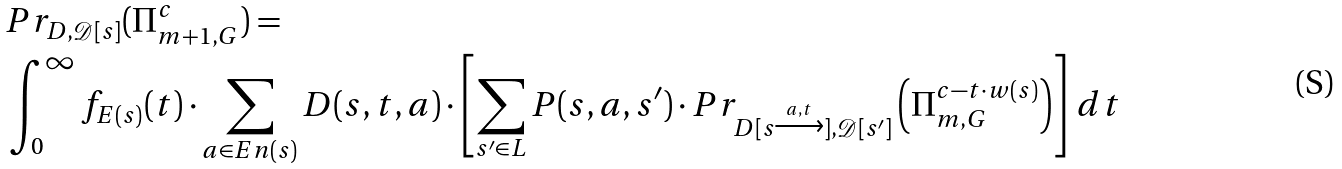<formula> <loc_0><loc_0><loc_500><loc_500>& P r _ { D , \mathcal { D } [ s ] } ( \Pi ^ { c } _ { m + 1 , G } ) = \\ & \int _ { 0 } ^ { \infty } f _ { E ( s ) } ( t ) \cdot \sum _ { a \in E n ( s ) } D ( s , t , a ) \cdot \left [ \sum _ { s ^ { \prime } \in L } P ( s , a , s ^ { \prime } ) \cdot P r _ { D [ s \xrightarrow { a , t } ] , \mathcal { D } [ s ^ { \prime } ] } \left ( \Pi _ { m , G } ^ { c - t \cdot w ( s ) } \right ) \right ] \, d t</formula> 